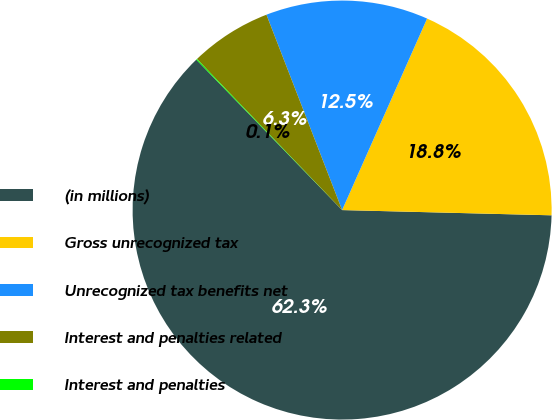<chart> <loc_0><loc_0><loc_500><loc_500><pie_chart><fcel>(in millions)<fcel>Gross unrecognized tax<fcel>Unrecognized tax benefits net<fcel>Interest and penalties related<fcel>Interest and penalties<nl><fcel>62.35%<fcel>18.75%<fcel>12.53%<fcel>6.3%<fcel>0.07%<nl></chart> 